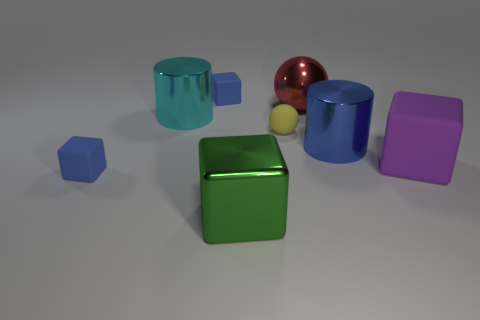Subtract 2 blocks. How many blocks are left? 2 Add 1 large cyan objects. How many objects exist? 9 Subtract all brown blocks. Subtract all brown balls. How many blocks are left? 4 Subtract all cylinders. How many objects are left? 6 Add 6 cylinders. How many cylinders exist? 8 Subtract 1 cyan cylinders. How many objects are left? 7 Subtract all tiny brown rubber things. Subtract all green shiny blocks. How many objects are left? 7 Add 7 yellow rubber spheres. How many yellow rubber spheres are left? 8 